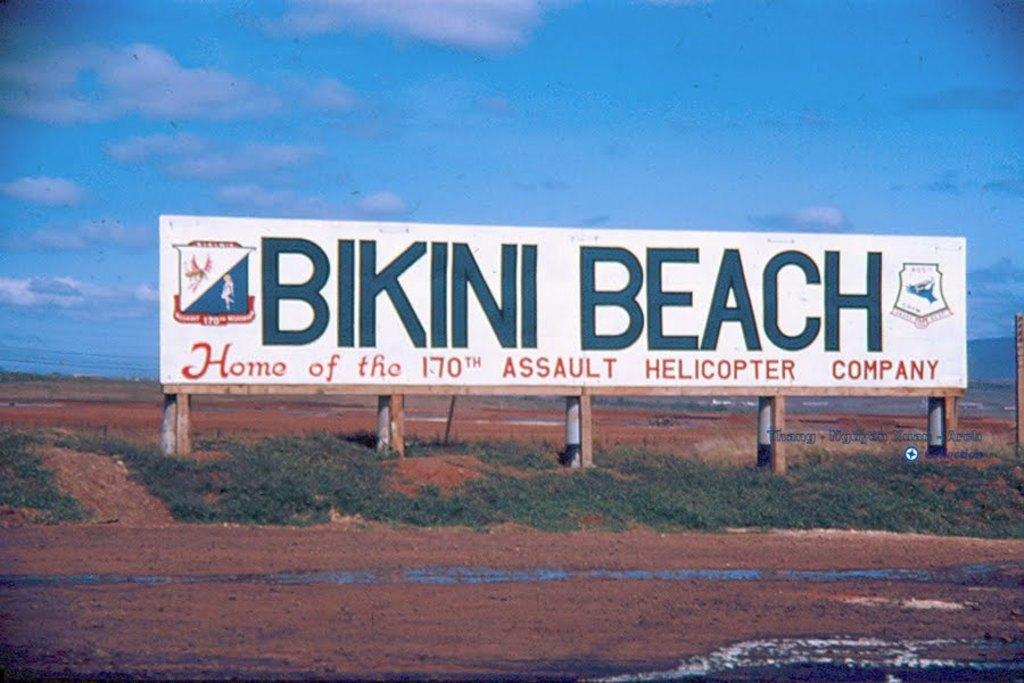<image>
Share a concise interpretation of the image provided. A white billboard sign that says Bikini Beach in blue letters 